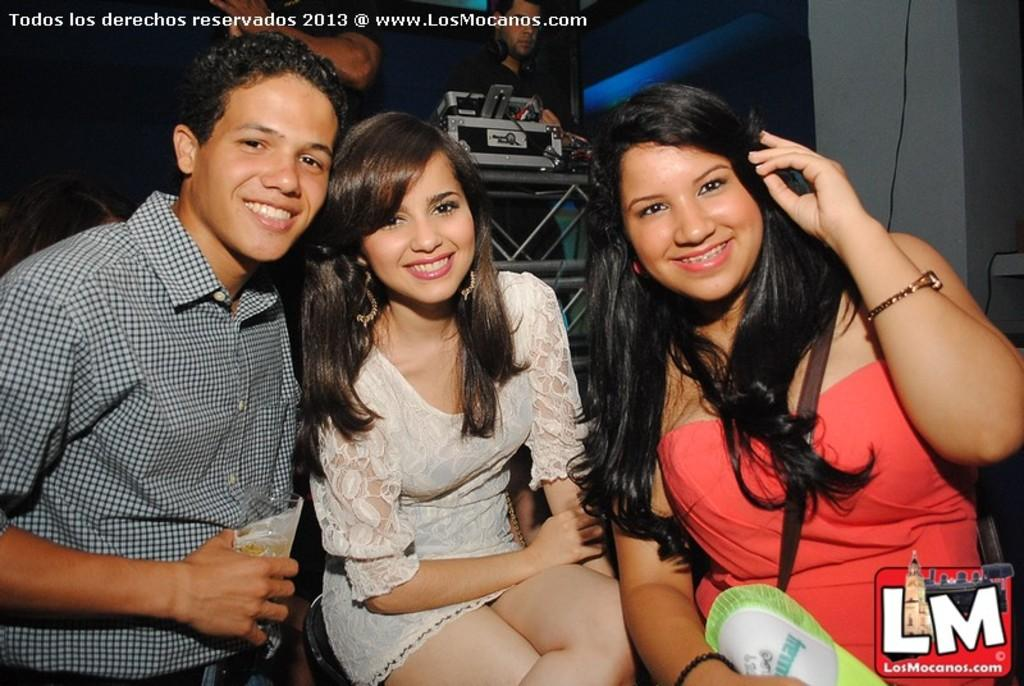How many people are in the image? There are people in the image, but the exact number is not specified. What is one person holding in the image? One person is holding a glass in the image. What object can be seen on the table in the image? There is an electronic instrument on the table in the image. What type of structure is visible in the image? There is a wall in the image. What type of object is present in the image that is typically used for transmitting signals or power? There is a wire in the image. What can be seen in the image that conveys information through written or printed symbols? There is text visible in the image. What type of quartz is visible on the wall in the image? There is no quartz visible on the wall in the image. What time of day is it in the image, specifically in the afternoon? The time of day is not specified in the image, so it cannot be determined if it is in the afternoon. 